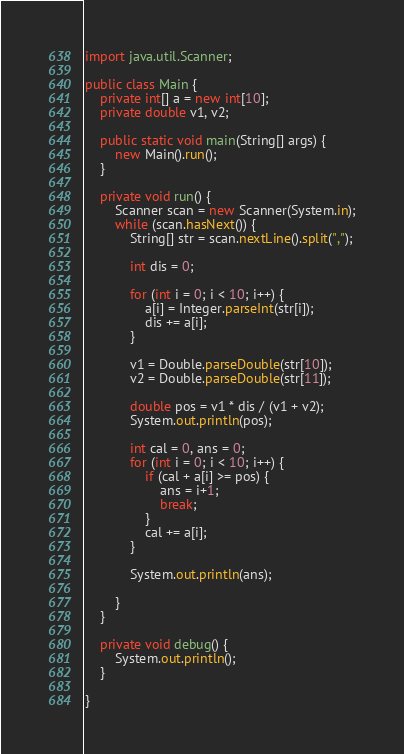<code> <loc_0><loc_0><loc_500><loc_500><_Java_>import java.util.Scanner;

public class Main {
	private int[] a = new int[10];
	private double v1, v2;

	public static void main(String[] args) {
		new Main().run();
	}
	
	private void run() {
		Scanner scan = new Scanner(System.in);
		while (scan.hasNext()) {
			String[] str = scan.nextLine().split(",");
			
			int dis = 0;
			
			for (int i = 0; i < 10; i++) {
				a[i] = Integer.parseInt(str[i]); 
				dis += a[i];
			}
			
			v1 = Double.parseDouble(str[10]);
			v2 = Double.parseDouble(str[11]);
			
			double pos = v1 * dis / (v1 + v2);
			System.out.println(pos);
			
			int cal = 0, ans = 0;
			for (int i = 0; i < 10; i++) {
				if (cal + a[i] >= pos) {
					ans = i+1;
					break;
				}
				cal += a[i];
			}
			
			System.out.println(ans);
			
		}
	}
	
	private void debug() {
		System.out.println();
	}

}</code> 